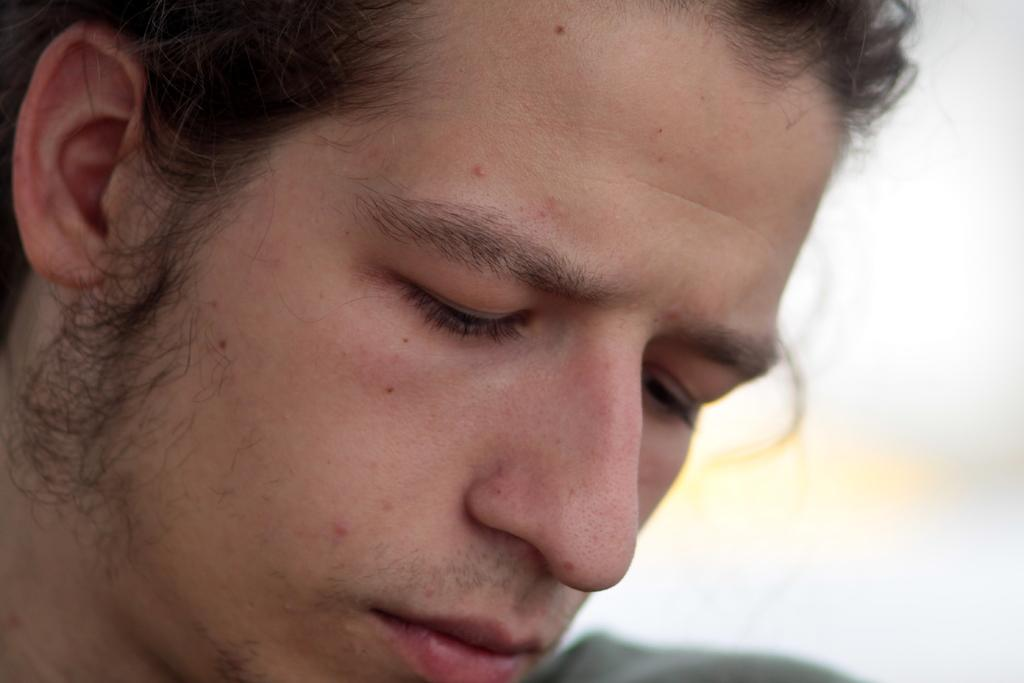What is the main subject of the image? There is a face of a person in the image. Can you see a ship in the quicksand in the image? There is no ship or quicksand present in the image; it only features the face of a person. 